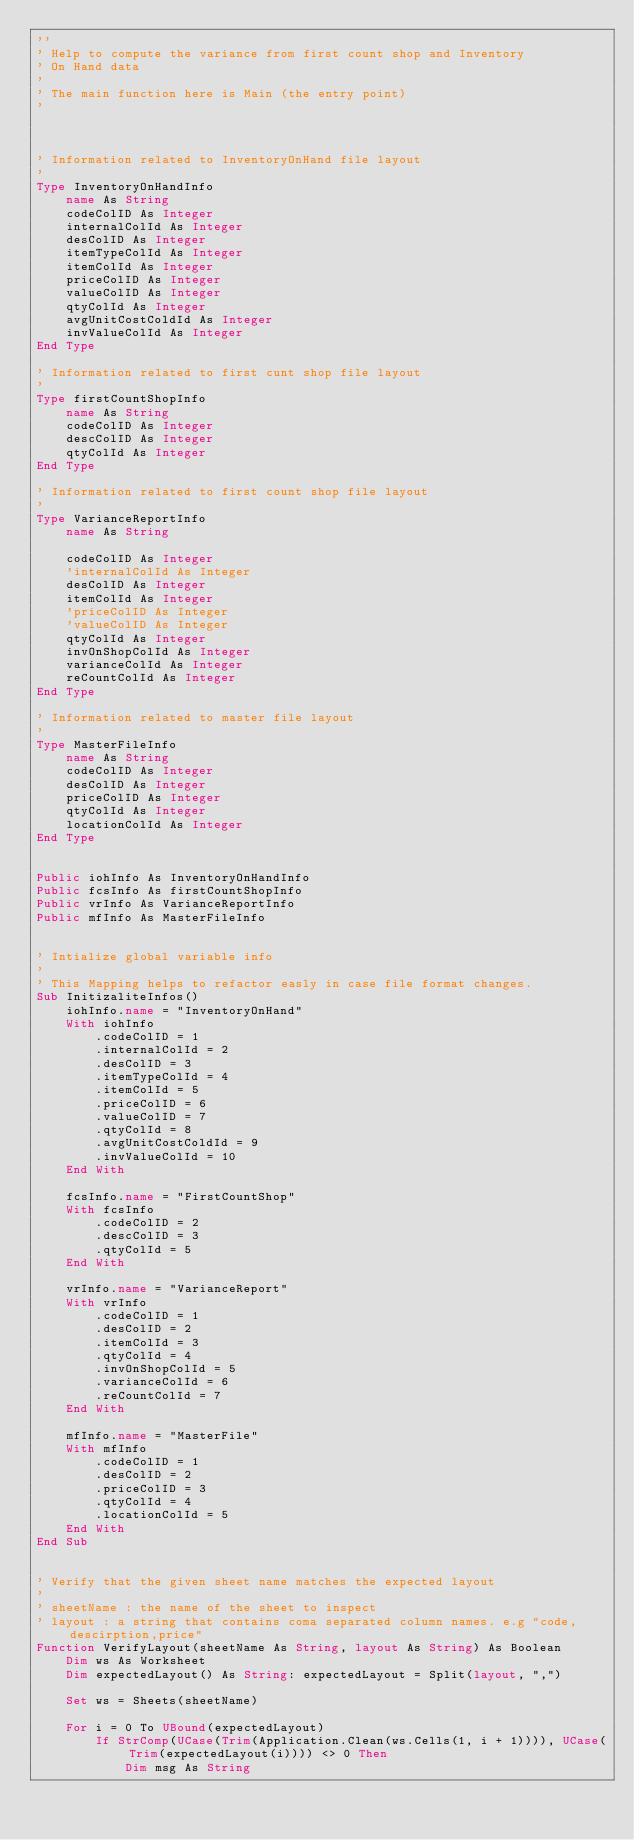<code> <loc_0><loc_0><loc_500><loc_500><_VisualBasic_>''
' Help to compute the variance from first count shop and Inventory
' On Hand data
'
' The main function here is Main (the entry point)
'



' Information related to InventoryOnHand file layout
'
Type InventoryOnHandInfo
    name As String
    codeColID As Integer
    internalColId As Integer
    desColID As Integer
    itemTypeColId As Integer
    itemColId As Integer
    priceColID As Integer
    valueColID As Integer
    qtyColId As Integer
    avgUnitCostColdId As Integer
    invValueColId As Integer
End Type

' Information related to first cunt shop file layout
'
Type firstCountShopInfo
    name As String
    codeColID As Integer
    descColID As Integer
    qtyColId As Integer
End Type

' Information related to first count shop file layout
'
Type VarianceReportInfo
    name As String
    
    codeColID As Integer
    'internalColId As Integer
    desColID As Integer
    itemColId As Integer
    'priceColID As Integer
    'valueColID As Integer
    qtyColId As Integer
    invOnShopColId As Integer
    varianceColId As Integer
    reCountColId As Integer
End Type

' Information related to master file layout
'
Type MasterFileInfo
    name As String
    codeColID As Integer
    desColID As Integer
    priceColID As Integer
    qtyColId As Integer
    locationColId As Integer
End Type


Public iohInfo As InventoryOnHandInfo
Public fcsInfo As firstCountShopInfo
Public vrInfo As VarianceReportInfo
Public mfInfo As MasterFileInfo


' Intialize global variable info
'
' This Mapping helps to refactor easly in case file format changes.
Sub InitizaliteInfos()
    iohInfo.name = "InventoryOnHand"
    With iohInfo
        .codeColID = 1
        .internalColId = 2
        .desColID = 3
        .itemTypeColId = 4
        .itemColId = 5
        .priceColID = 6
        .valueColID = 7
        .qtyColId = 8
        .avgUnitCostColdId = 9
        .invValueColId = 10
    End With
    
    fcsInfo.name = "FirstCountShop"
    With fcsInfo
        .codeColID = 2
        .descColID = 3
        .qtyColId = 5
    End With

    vrInfo.name = "VarianceReport"
    With vrInfo
        .codeColID = 1
        .desColID = 2
        .itemColId = 3
        .qtyColId = 4
        .invOnShopColId = 5
        .varianceColId = 6
        .reCountColId = 7
    End With

    mfInfo.name = "MasterFile"
    With mfInfo
        .codeColID = 1
        .desColID = 2
        .priceColID = 3
        .qtyColId = 4
        .locationColId = 5
    End With
End Sub


' Verify that the given sheet name matches the expected layout
'
' sheetName : the name of the sheet to inspect
' layout : a string that contains coma separated column names. e.g "code,descirption,price"
Function VerifyLayout(sheetName As String, layout As String) As Boolean
    Dim ws As Worksheet
    Dim expectedLayout() As String: expectedLayout = Split(layout, ",")

    Set ws = Sheets(sheetName)

    For i = 0 To UBound(expectedLayout)
        If StrComp(UCase(Trim(Application.Clean(ws.Cells(1, i + 1)))), UCase(Trim(expectedLayout(i)))) <> 0 Then
            Dim msg As String</code> 